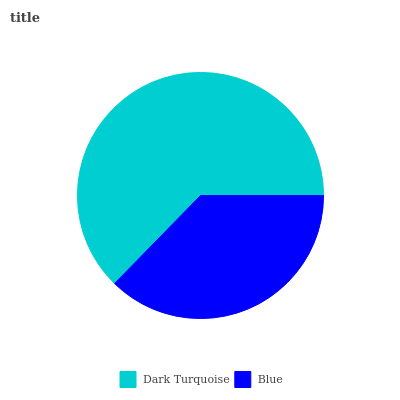Is Blue the minimum?
Answer yes or no. Yes. Is Dark Turquoise the maximum?
Answer yes or no. Yes. Is Blue the maximum?
Answer yes or no. No. Is Dark Turquoise greater than Blue?
Answer yes or no. Yes. Is Blue less than Dark Turquoise?
Answer yes or no. Yes. Is Blue greater than Dark Turquoise?
Answer yes or no. No. Is Dark Turquoise less than Blue?
Answer yes or no. No. Is Dark Turquoise the high median?
Answer yes or no. Yes. Is Blue the low median?
Answer yes or no. Yes. Is Blue the high median?
Answer yes or no. No. Is Dark Turquoise the low median?
Answer yes or no. No. 